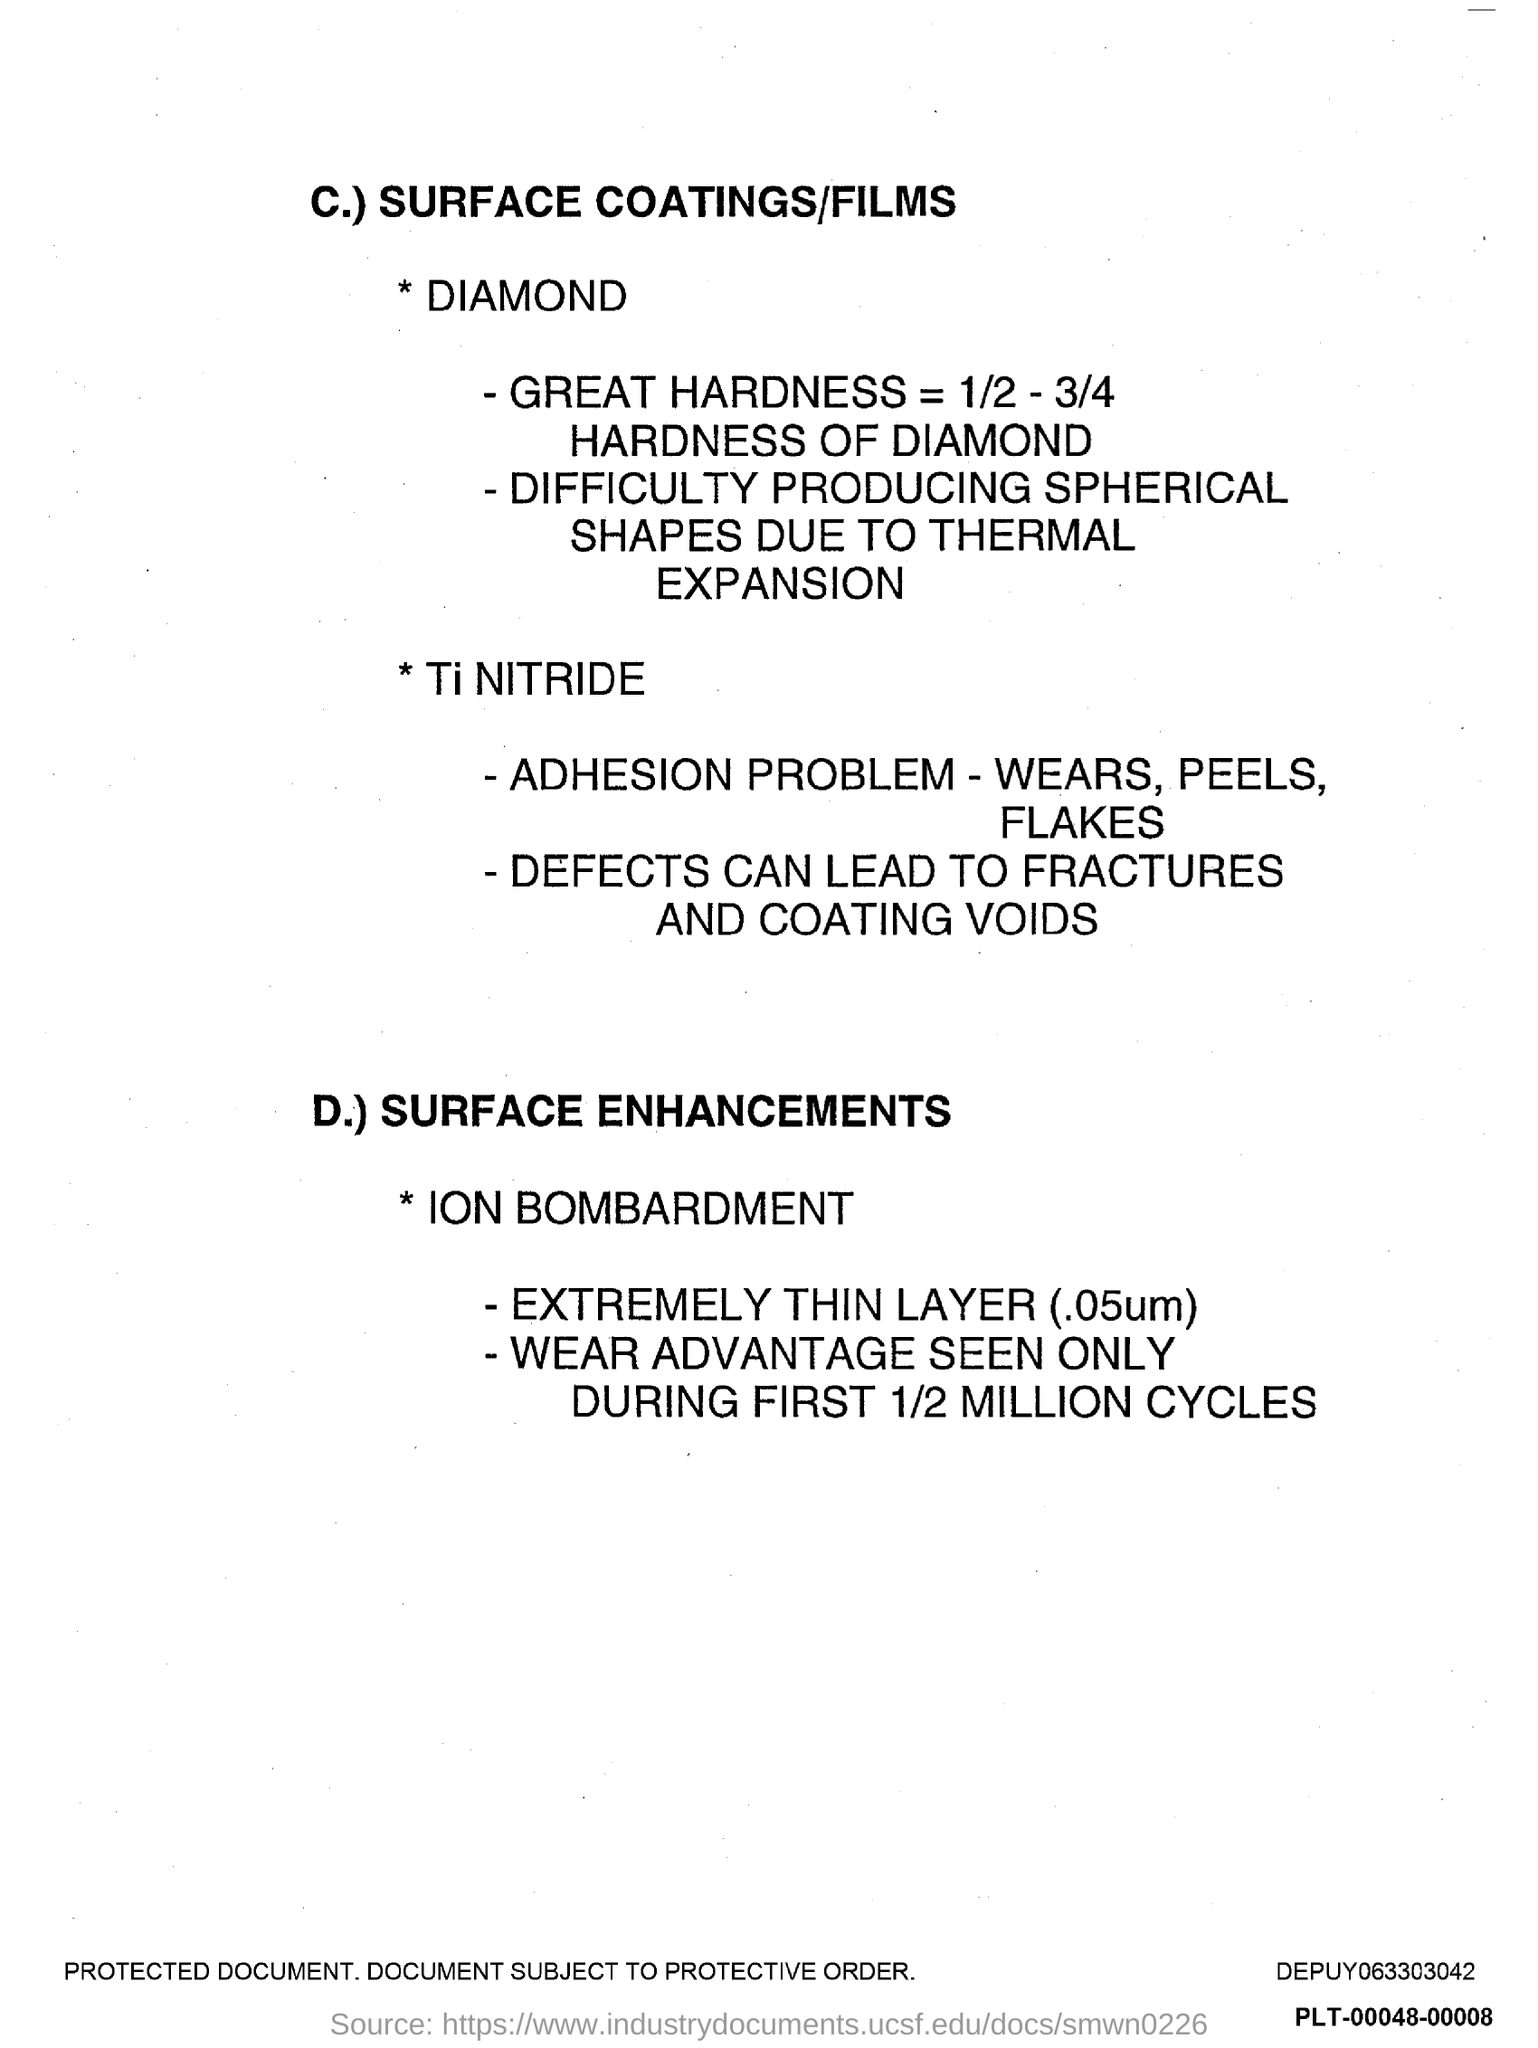Indicate a few pertinent items in this graphic. The first title in the document is 'SURFACE COATINGS/FILMS.' 